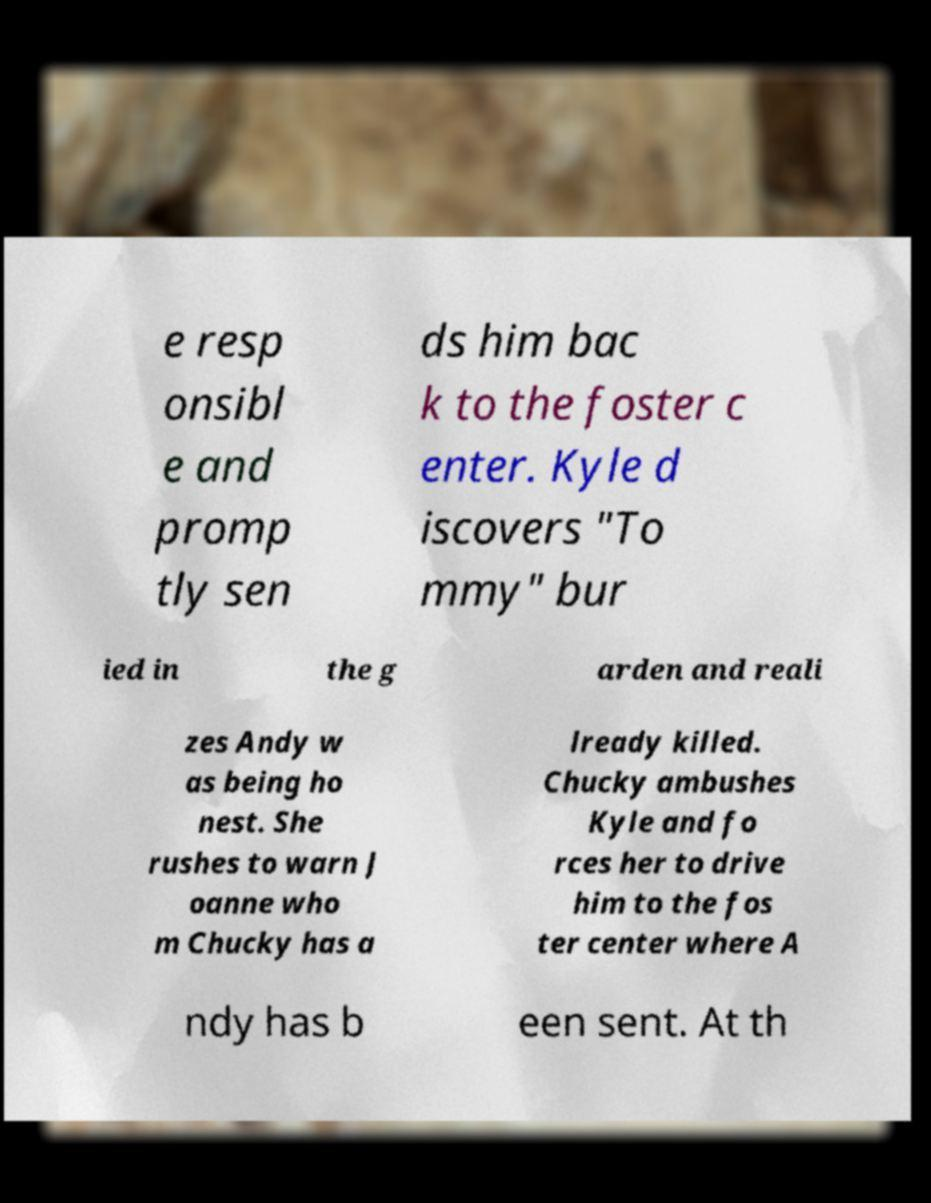Could you extract and type out the text from this image? e resp onsibl e and promp tly sen ds him bac k to the foster c enter. Kyle d iscovers "To mmy" bur ied in the g arden and reali zes Andy w as being ho nest. She rushes to warn J oanne who m Chucky has a lready killed. Chucky ambushes Kyle and fo rces her to drive him to the fos ter center where A ndy has b een sent. At th 